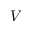<formula> <loc_0><loc_0><loc_500><loc_500>V</formula> 